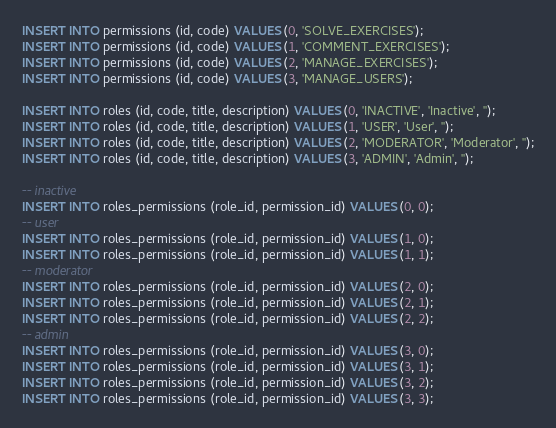Convert code to text. <code><loc_0><loc_0><loc_500><loc_500><_SQL_>INSERT INTO permissions (id, code) VALUES (0, 'SOLVE_EXERCISES');
INSERT INTO permissions (id, code) VALUES (1, 'COMMENT_EXERCISES');
INSERT INTO permissions (id, code) VALUES (2, 'MANAGE_EXERCISES');
INSERT INTO permissions (id, code) VALUES (3, 'MANAGE_USERS');

INSERT INTO roles (id, code, title, description) VALUES (0, 'INACTIVE', 'Inactive', '');
INSERT INTO roles (id, code, title, description) VALUES (1, 'USER', 'User', '');
INSERT INTO roles (id, code, title, description) VALUES (2, 'MODERATOR', 'Moderator', '');
INSERT INTO roles (id, code, title, description) VALUES (3, 'ADMIN', 'Admin', '');

-- inactive
INSERT INTO roles_permissions (role_id, permission_id) VALUES (0, 0);
-- user
INSERT INTO roles_permissions (role_id, permission_id) VALUES (1, 0);
INSERT INTO roles_permissions (role_id, permission_id) VALUES (1, 1);
-- moderator
INSERT INTO roles_permissions (role_id, permission_id) VALUES (2, 0);
INSERT INTO roles_permissions (role_id, permission_id) VALUES (2, 1);
INSERT INTO roles_permissions (role_id, permission_id) VALUES (2, 2);
-- admin
INSERT INTO roles_permissions (role_id, permission_id) VALUES (3, 0);
INSERT INTO roles_permissions (role_id, permission_id) VALUES (3, 1);
INSERT INTO roles_permissions (role_id, permission_id) VALUES (3, 2);
INSERT INTO roles_permissions (role_id, permission_id) VALUES (3, 3);</code> 